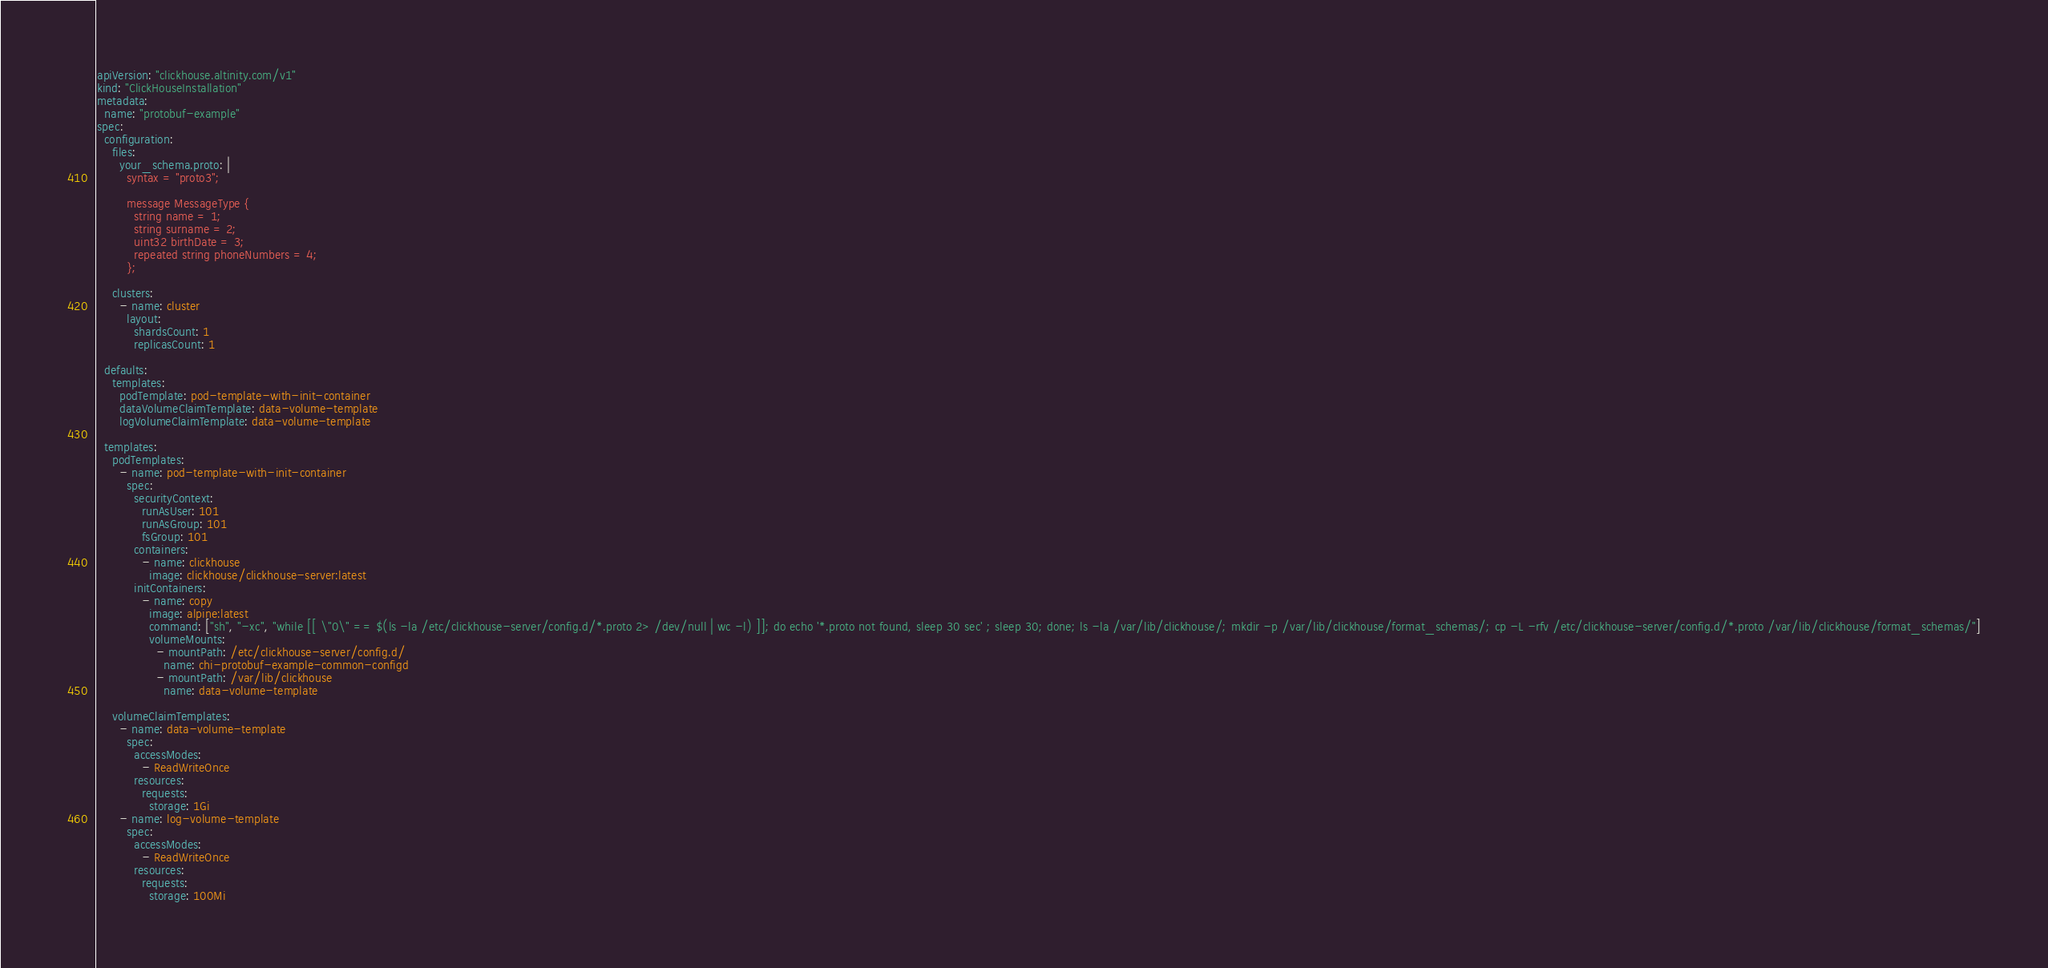<code> <loc_0><loc_0><loc_500><loc_500><_YAML_>apiVersion: "clickhouse.altinity.com/v1"
kind: "ClickHouseInstallation"
metadata:
  name: "protobuf-example"
spec:
  configuration:
    files:
      your_schema.proto: |
        syntax = "proto3";

        message MessageType {
          string name = 1;
          string surname = 2;
          uint32 birthDate = 3;
          repeated string phoneNumbers = 4;
        };

    clusters:
      - name: cluster
        layout:
          shardsCount: 1
          replicasCount: 1

  defaults:
    templates:
      podTemplate: pod-template-with-init-container
      dataVolumeClaimTemplate: data-volume-template
      logVolumeClaimTemplate: data-volume-template

  templates:
    podTemplates:
      - name: pod-template-with-init-container
        spec:
          securityContext:
            runAsUser: 101
            runAsGroup: 101
            fsGroup: 101
          containers:
            - name: clickhouse
              image: clickhouse/clickhouse-server:latest
          initContainers:
            - name: copy
              image: alpine:latest
              command: ["sh", "-xc", "while [[ \"0\" == $(ls -la /etc/clickhouse-server/config.d/*.proto 2> /dev/null | wc -l) ]]; do echo '*.proto not found, sleep 30 sec' ; sleep 30; done; ls -la /var/lib/clickhouse/; mkdir -p /var/lib/clickhouse/format_schemas/; cp -L -rfv /etc/clickhouse-server/config.d/*.proto /var/lib/clickhouse/format_schemas/"]
              volumeMounts:
                - mountPath: /etc/clickhouse-server/config.d/
                  name: chi-protobuf-example-common-configd
                - mountPath: /var/lib/clickhouse
                  name: data-volume-template

    volumeClaimTemplates:
      - name: data-volume-template
        spec:
          accessModes:
            - ReadWriteOnce
          resources:
            requests:
              storage: 1Gi
      - name: log-volume-template
        spec:
          accessModes:
            - ReadWriteOnce
          resources:
            requests:
              storage: 100Mi
</code> 